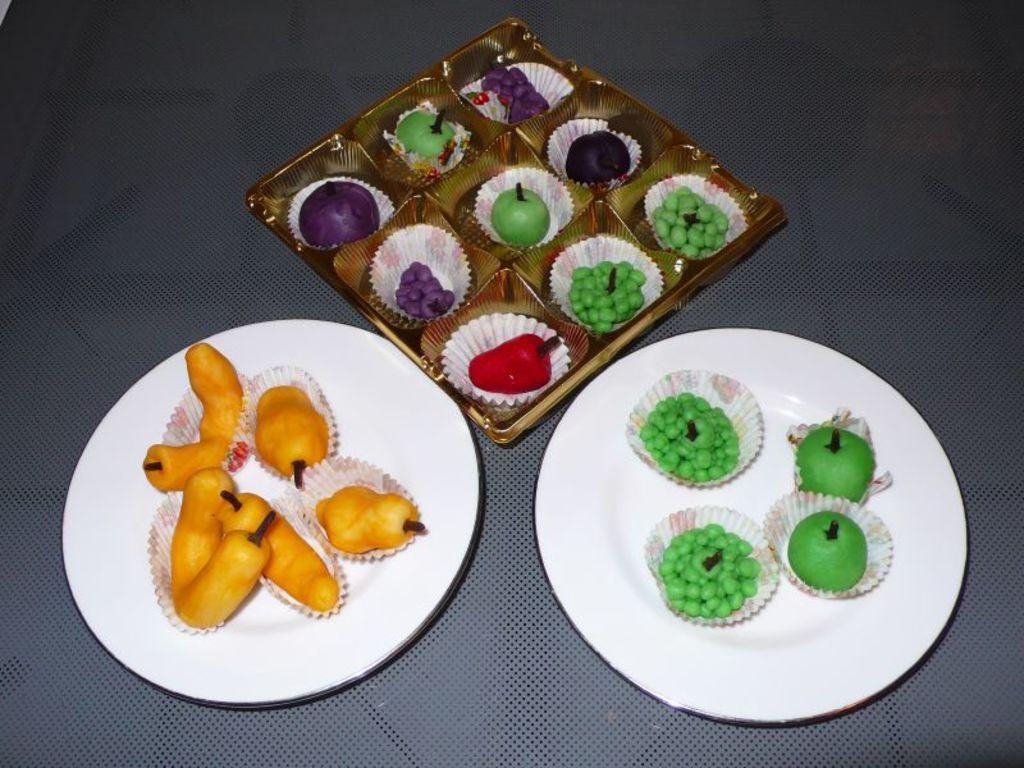Could you give a brief overview of what you see in this image? In this image I can see two plates and a box which consists of some food items in the wrappers. These are placed on a blue surface. 